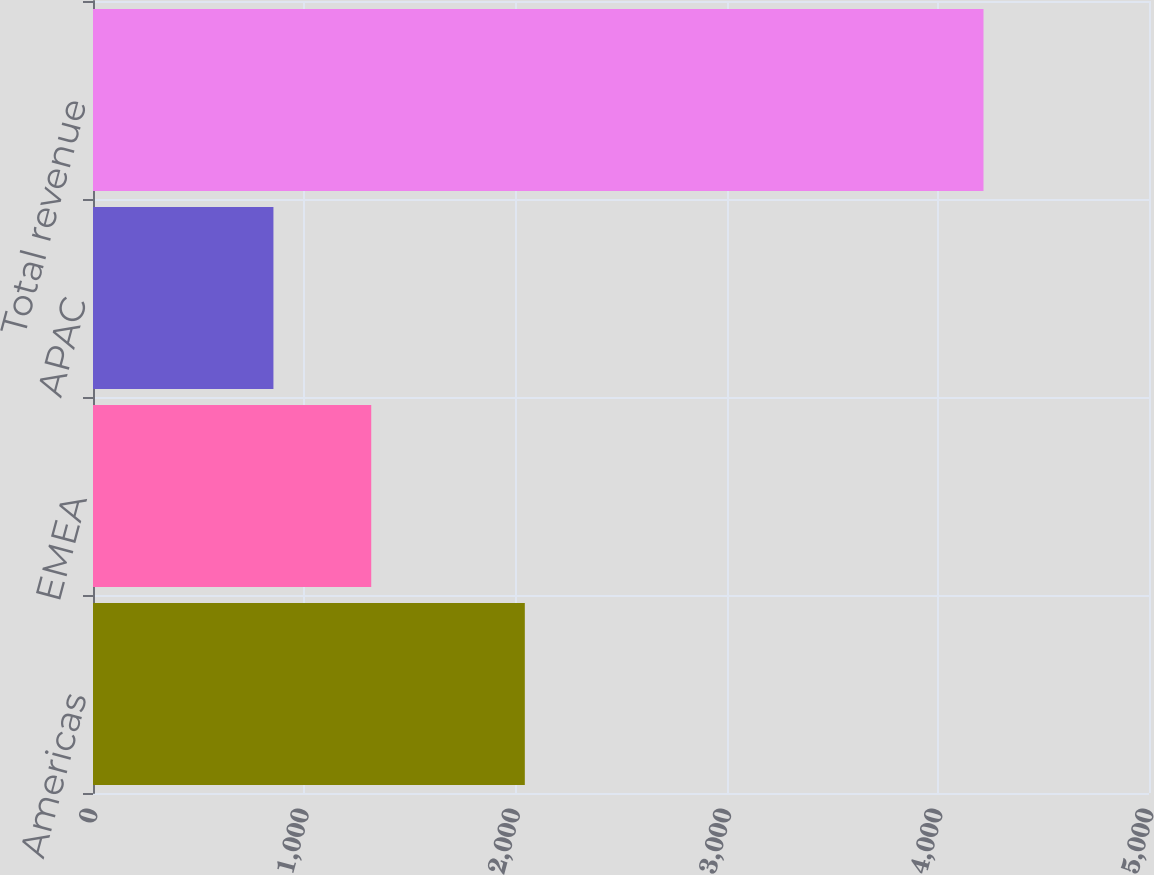Convert chart to OTSL. <chart><loc_0><loc_0><loc_500><loc_500><bar_chart><fcel>Americas<fcel>EMEA<fcel>APAC<fcel>Total revenue<nl><fcel>2044.6<fcel>1317.4<fcel>854.3<fcel>4216.3<nl></chart> 